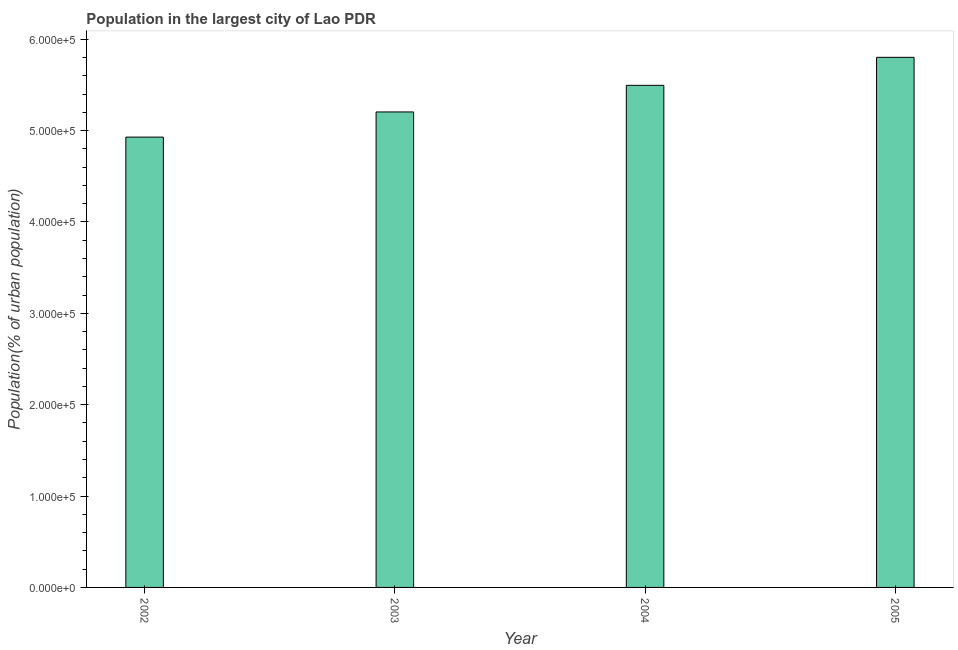What is the title of the graph?
Your response must be concise. Population in the largest city of Lao PDR. What is the label or title of the Y-axis?
Offer a terse response. Population(% of urban population). What is the population in largest city in 2003?
Your answer should be very brief. 5.20e+05. Across all years, what is the maximum population in largest city?
Provide a succinct answer. 5.80e+05. Across all years, what is the minimum population in largest city?
Offer a terse response. 4.93e+05. In which year was the population in largest city maximum?
Your answer should be compact. 2005. What is the sum of the population in largest city?
Your response must be concise. 2.14e+06. What is the difference between the population in largest city in 2003 and 2005?
Your response must be concise. -5.98e+04. What is the average population in largest city per year?
Provide a short and direct response. 5.36e+05. What is the median population in largest city?
Your response must be concise. 5.35e+05. What is the ratio of the population in largest city in 2003 to that in 2004?
Provide a short and direct response. 0.95. Is the difference between the population in largest city in 2002 and 2005 greater than the difference between any two years?
Provide a succinct answer. Yes. What is the difference between the highest and the second highest population in largest city?
Provide a succinct answer. 3.07e+04. Is the sum of the population in largest city in 2003 and 2004 greater than the maximum population in largest city across all years?
Your response must be concise. Yes. What is the difference between the highest and the lowest population in largest city?
Ensure brevity in your answer.  8.73e+04. In how many years, is the population in largest city greater than the average population in largest city taken over all years?
Ensure brevity in your answer.  2. Are all the bars in the graph horizontal?
Provide a short and direct response. No. Are the values on the major ticks of Y-axis written in scientific E-notation?
Make the answer very short. Yes. What is the Population(% of urban population) in 2002?
Your answer should be compact. 4.93e+05. What is the Population(% of urban population) in 2003?
Give a very brief answer. 5.20e+05. What is the Population(% of urban population) in 2004?
Your answer should be very brief. 5.50e+05. What is the Population(% of urban population) in 2005?
Offer a terse response. 5.80e+05. What is the difference between the Population(% of urban population) in 2002 and 2003?
Ensure brevity in your answer.  -2.75e+04. What is the difference between the Population(% of urban population) in 2002 and 2004?
Give a very brief answer. -5.67e+04. What is the difference between the Population(% of urban population) in 2002 and 2005?
Your answer should be very brief. -8.73e+04. What is the difference between the Population(% of urban population) in 2003 and 2004?
Give a very brief answer. -2.91e+04. What is the difference between the Population(% of urban population) in 2003 and 2005?
Offer a very short reply. -5.98e+04. What is the difference between the Population(% of urban population) in 2004 and 2005?
Provide a short and direct response. -3.07e+04. What is the ratio of the Population(% of urban population) in 2002 to that in 2003?
Your answer should be compact. 0.95. What is the ratio of the Population(% of urban population) in 2002 to that in 2004?
Provide a short and direct response. 0.9. What is the ratio of the Population(% of urban population) in 2002 to that in 2005?
Ensure brevity in your answer.  0.85. What is the ratio of the Population(% of urban population) in 2003 to that in 2004?
Offer a terse response. 0.95. What is the ratio of the Population(% of urban population) in 2003 to that in 2005?
Make the answer very short. 0.9. What is the ratio of the Population(% of urban population) in 2004 to that in 2005?
Ensure brevity in your answer.  0.95. 